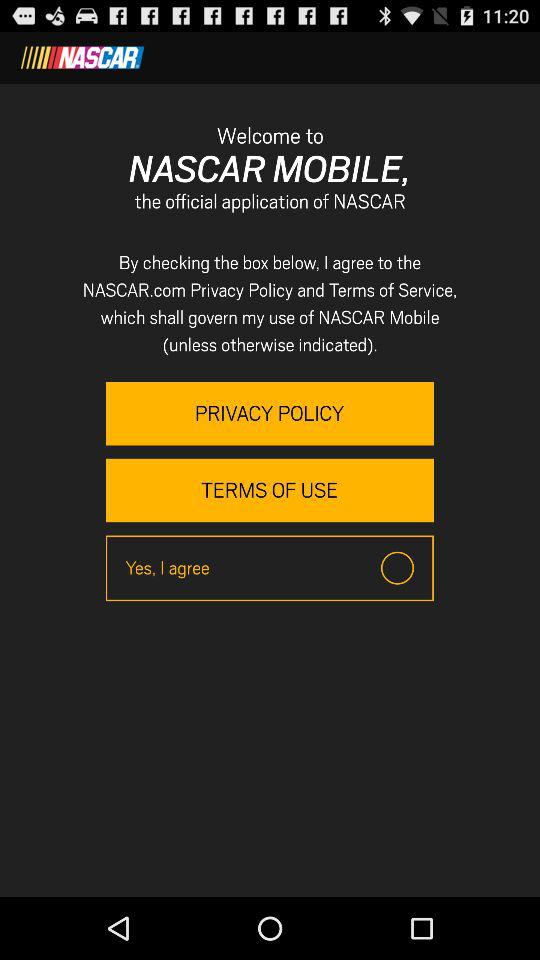What is the application name? The application name is Nascar Mobile. 